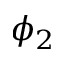<formula> <loc_0><loc_0><loc_500><loc_500>\phi _ { 2 }</formula> 